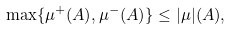Convert formula to latex. <formula><loc_0><loc_0><loc_500><loc_500>\, \max \{ \mu ^ { + } ( A ) , \mu ^ { - } ( A ) \} \leq | \mu | ( A ) ,</formula> 